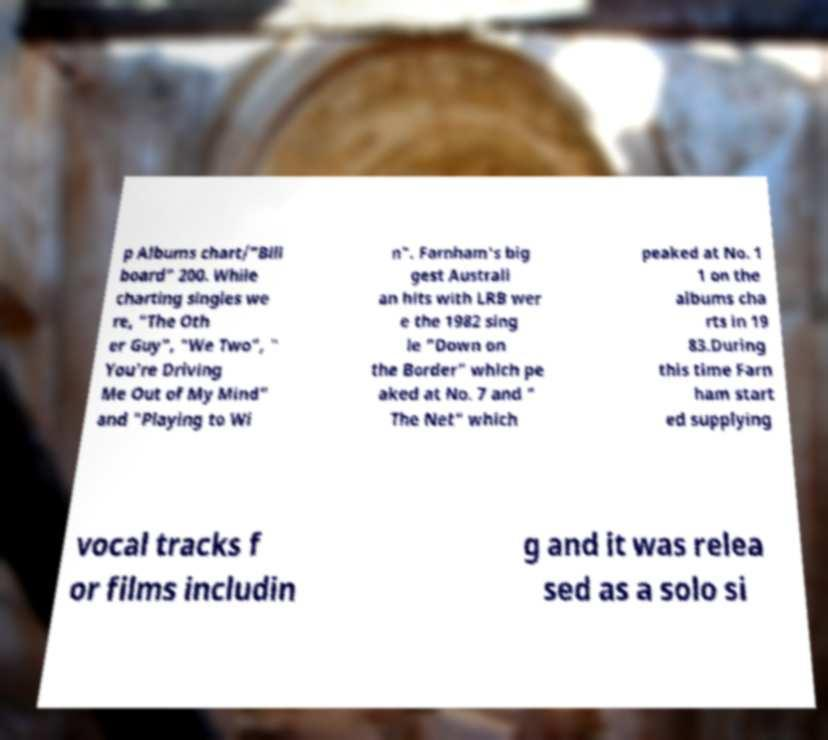For documentation purposes, I need the text within this image transcribed. Could you provide that? p Albums chart/"Bill board" 200. While charting singles we re, "The Oth er Guy", "We Two", " You're Driving Me Out of My Mind" and "Playing to Wi n". Farnham's big gest Australi an hits with LRB wer e the 1982 sing le "Down on the Border" which pe aked at No. 7 and " The Net" which peaked at No. 1 1 on the albums cha rts in 19 83.During this time Farn ham start ed supplying vocal tracks f or films includin g and it was relea sed as a solo si 